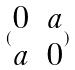Convert formula to latex. <formula><loc_0><loc_0><loc_500><loc_500>( \begin{matrix} 0 & a \\ a & 0 \end{matrix} )</formula> 